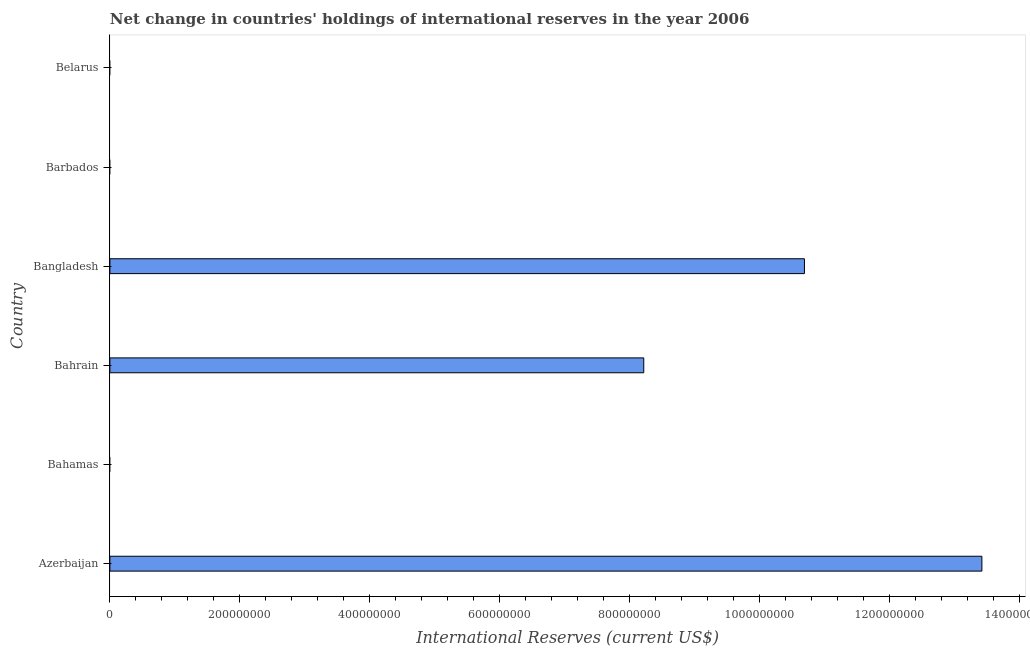Does the graph contain grids?
Your response must be concise. No. What is the title of the graph?
Give a very brief answer. Net change in countries' holdings of international reserves in the year 2006. What is the label or title of the X-axis?
Ensure brevity in your answer.  International Reserves (current US$). What is the reserves and related items in Bahrain?
Provide a short and direct response. 8.22e+08. Across all countries, what is the maximum reserves and related items?
Your response must be concise. 1.34e+09. In which country was the reserves and related items maximum?
Offer a very short reply. Azerbaijan. What is the sum of the reserves and related items?
Your response must be concise. 3.23e+09. What is the difference between the reserves and related items in Azerbaijan and Bahrain?
Ensure brevity in your answer.  5.21e+08. What is the average reserves and related items per country?
Provide a succinct answer. 5.39e+08. What is the median reserves and related items?
Your response must be concise. 4.11e+08. In how many countries, is the reserves and related items greater than 560000000 US$?
Keep it short and to the point. 3. What is the ratio of the reserves and related items in Bahrain to that in Bangladesh?
Keep it short and to the point. 0.77. What is the difference between the highest and the second highest reserves and related items?
Give a very brief answer. 2.73e+08. Is the sum of the reserves and related items in Azerbaijan and Bangladesh greater than the maximum reserves and related items across all countries?
Your answer should be very brief. Yes. What is the difference between the highest and the lowest reserves and related items?
Offer a terse response. 1.34e+09. Are all the bars in the graph horizontal?
Your answer should be compact. Yes. How many countries are there in the graph?
Offer a very short reply. 6. What is the International Reserves (current US$) of Azerbaijan?
Give a very brief answer. 1.34e+09. What is the International Reserves (current US$) of Bahamas?
Give a very brief answer. 0. What is the International Reserves (current US$) of Bahrain?
Give a very brief answer. 8.22e+08. What is the International Reserves (current US$) of Bangladesh?
Your response must be concise. 1.07e+09. What is the difference between the International Reserves (current US$) in Azerbaijan and Bahrain?
Keep it short and to the point. 5.21e+08. What is the difference between the International Reserves (current US$) in Azerbaijan and Bangladesh?
Provide a short and direct response. 2.73e+08. What is the difference between the International Reserves (current US$) in Bahrain and Bangladesh?
Keep it short and to the point. -2.47e+08. What is the ratio of the International Reserves (current US$) in Azerbaijan to that in Bahrain?
Make the answer very short. 1.63. What is the ratio of the International Reserves (current US$) in Azerbaijan to that in Bangladesh?
Provide a short and direct response. 1.25. What is the ratio of the International Reserves (current US$) in Bahrain to that in Bangladesh?
Give a very brief answer. 0.77. 